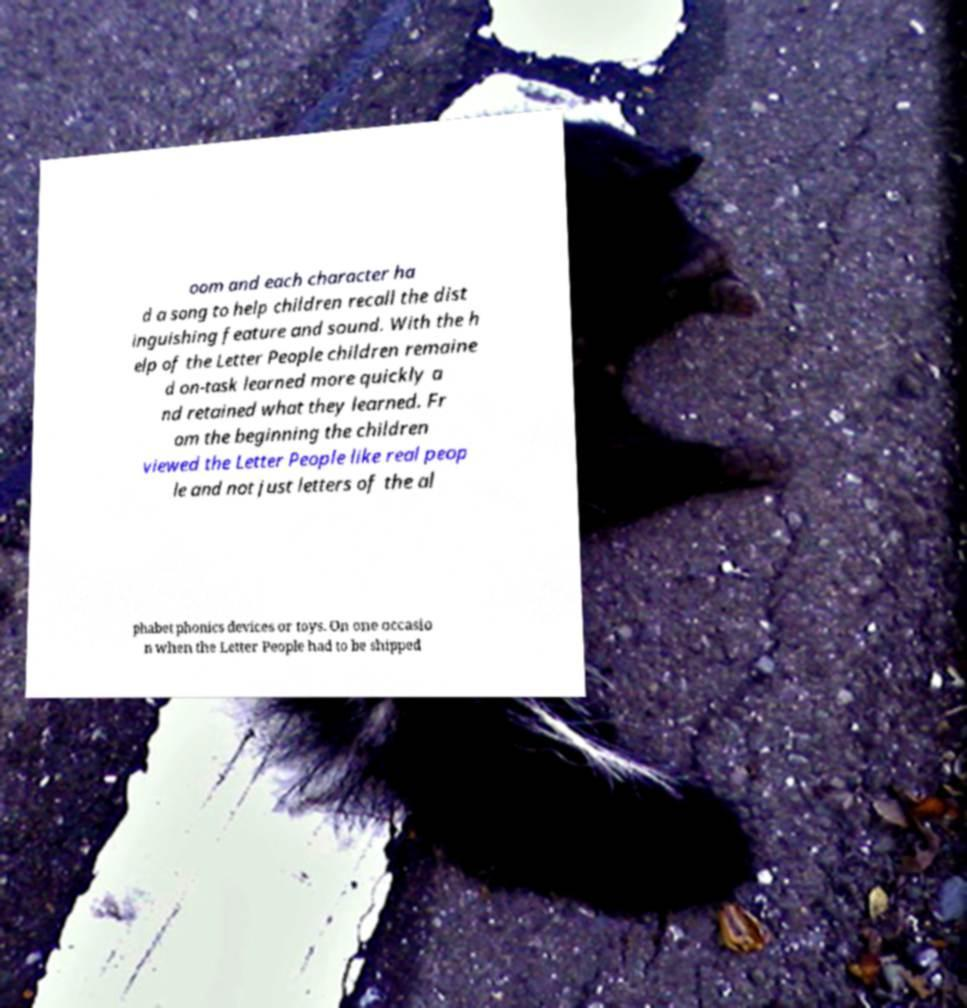Can you accurately transcribe the text from the provided image for me? oom and each character ha d a song to help children recall the dist inguishing feature and sound. With the h elp of the Letter People children remaine d on-task learned more quickly a nd retained what they learned. Fr om the beginning the children viewed the Letter People like real peop le and not just letters of the al phabet phonics devices or toys. On one occasio n when the Letter People had to be shipped 